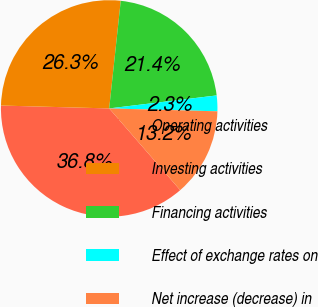<chart> <loc_0><loc_0><loc_500><loc_500><pie_chart><fcel>Operating activities<fcel>Investing activities<fcel>Financing activities<fcel>Effect of exchange rates on<fcel>Net increase (decrease) in<nl><fcel>36.81%<fcel>26.28%<fcel>21.38%<fcel>2.34%<fcel>13.19%<nl></chart> 